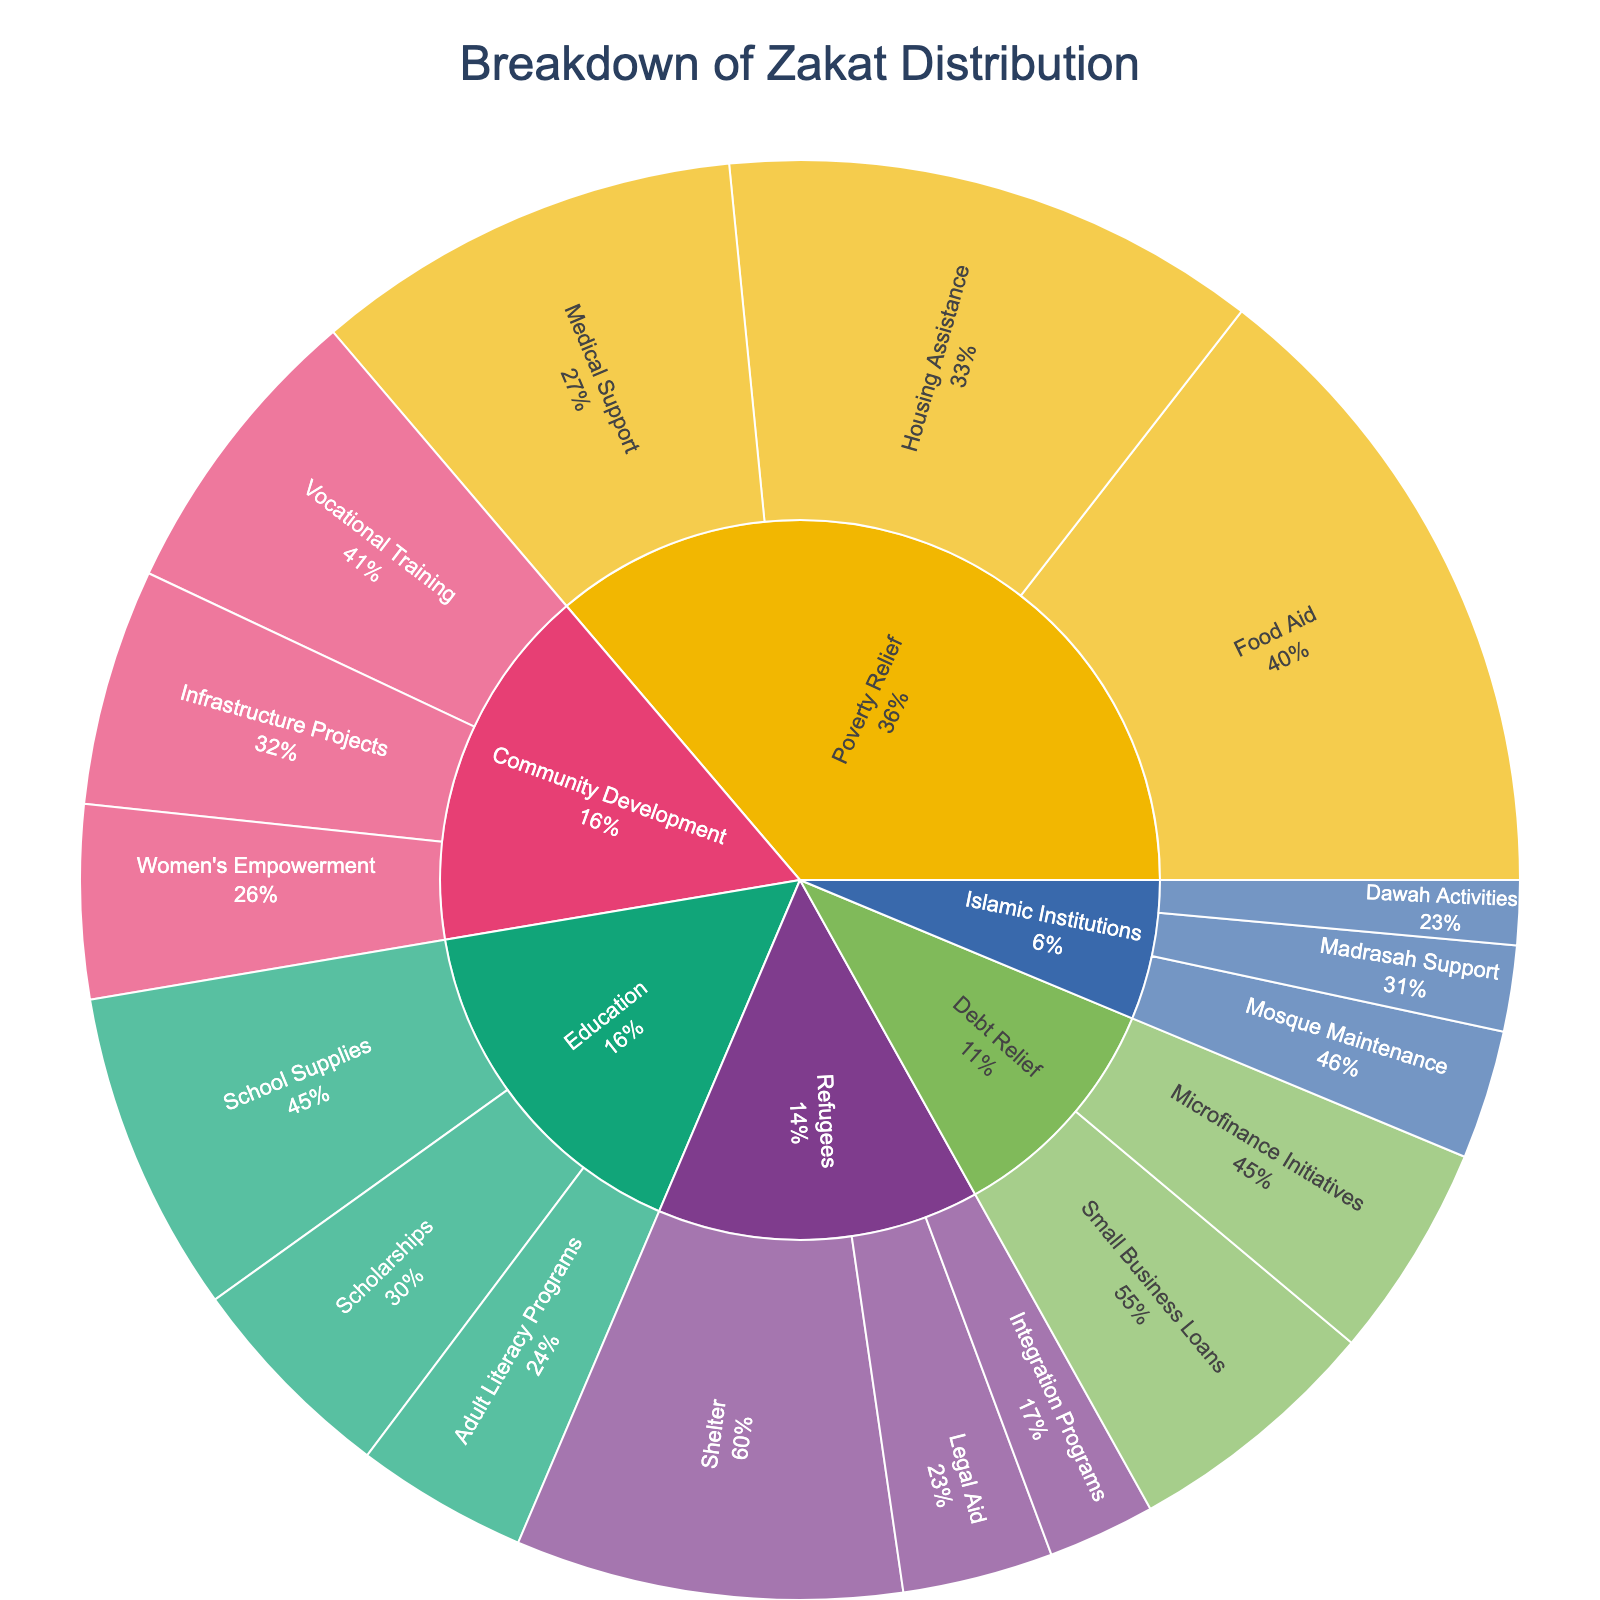What is the title of the sunburst chart? The title of the chart is displayed at the top center of the figure. It provides a short description of the contents and purpose of the chart.
Answer: Breakdown of Zakat Distribution Which category receives the most significant portion of Zakat distribution? By observing the central segments of the sunburst chart, we can see the largest portion of the chart. The "Poverty Relief" segment clearly holds the most significant portion.
Answer: Poverty Relief What percentage of the "Education" category is allocated to "School Supplies"? First, find the proportion of "School Supplies" within the "Education" segment. The "School Supplies" value is 15, and the total for "Education" is 15 + 10 + 8 = 33. The percentage is obtained by (15/33) * 100.
Answer: 45.5% How much total Zakat is allocated to "Community Development"? Sum the values of all subcategories under "Community Development". The values are 14 (Vocational Training) + 11 (Infrastructure Projects) + 9 (Women's Empowerment). Adding these gives the total.
Answer: 34 Which subcategory within "Refugees" receives the least amount of Zakat? By comparing the subcategories within the "Refugees" section, we can identify the one with the smallest value. "Integration Programs" has the smallest value.
Answer: Integration Programs How does the amount allocated to "Microfinance Initiatives" compare to "Small Business Loans"? Compare the values directly. "Small Business Loans" has a value of 12, while "Microfinance Initiatives" has a value of 10. Comparing them shows that "Small Business Loans" receives more.
Answer: Small Business Loans What is the total Zakat allocated to "Debt Relief" and "Refugees" combined? Sum the total values of both "Debt Relief" and "Refugees". For "Debt Relief", the sum is 12+10=22. For "Refugees", the sum is 18+7+5=30. Adding these totals gives the combined amount.
Answer: 52 What is the largest subcategory in terms of Zakat allocation? Compare all subcategories across the chart to find the one with the highest value. The value 30 for "Food Aid" under "Poverty Relief" is the largest single subcategory value.
Answer: Food Aid What percent of "Poverty Relief" funds are used for "Medical Support"? Find the percentage of "Medical Support" within "Poverty Relief". The "Medical Support" value is 20, and the total for "Poverty Relief" is 30 + 25 + 20 = 75. The percentage is (20/75) * 100.
Answer: 26.7% Is more Zakat allocated to "Women's Empowerment" or "Vocational Training" under "Community Development"? Compare the values directly. "Women's Empowerment" is 9, and "Vocational Training" is 14. "Vocational Training" receives more.
Answer: Vocational Training 